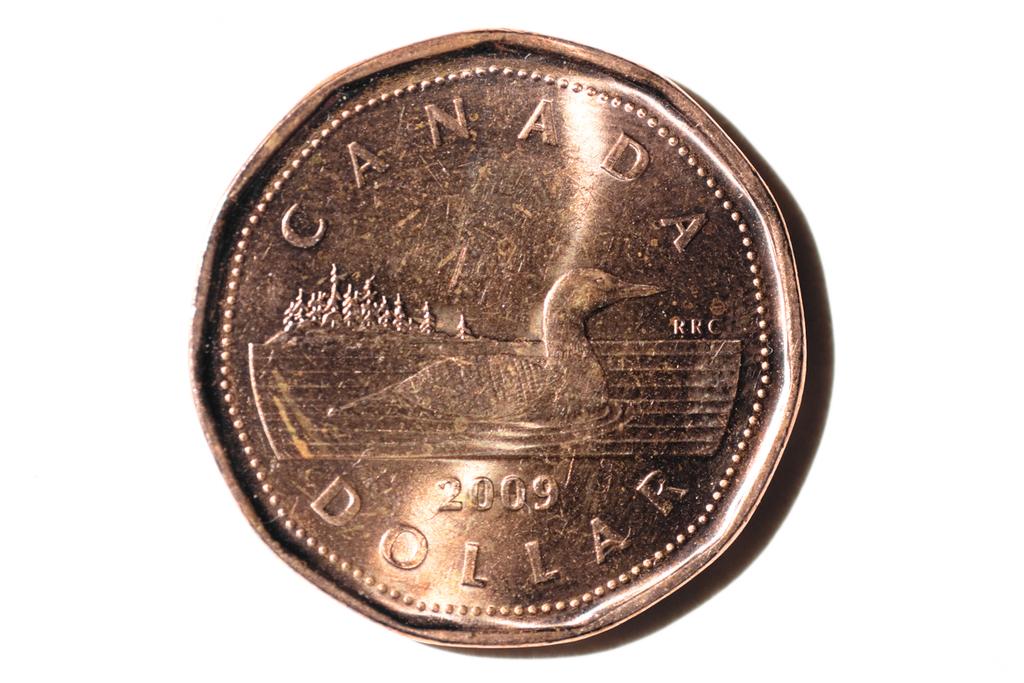Where did this coin originate?
Provide a short and direct response. Canada. What year was this coin minted?
Your answer should be very brief. 2009. 